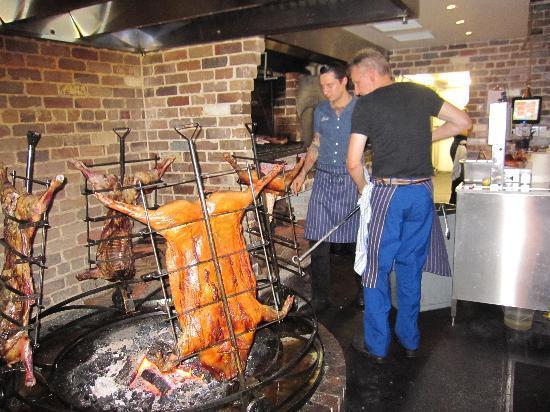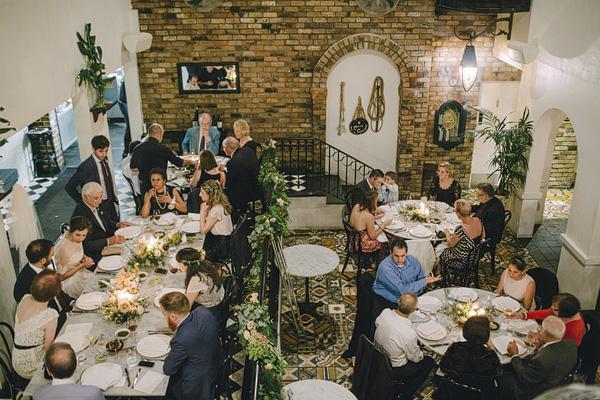The first image is the image on the left, the second image is the image on the right. Examine the images to the left and right. Is the description "They are roasting pigs in one of the images." accurate? Answer yes or no. Yes. The first image is the image on the left, the second image is the image on the right. For the images displayed, is the sentence "There are pigs surrounding a fire pit." factually correct? Answer yes or no. Yes. 